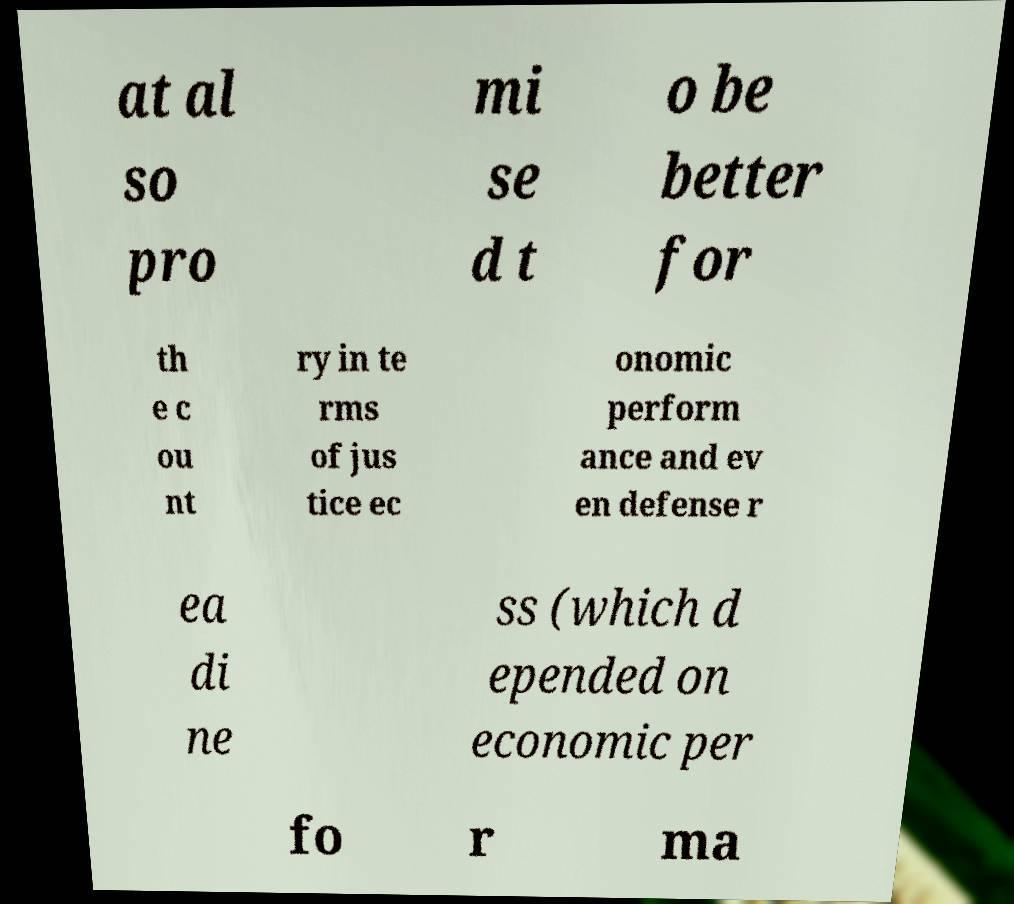There's text embedded in this image that I need extracted. Can you transcribe it verbatim? at al so pro mi se d t o be better for th e c ou nt ry in te rms of jus tice ec onomic perform ance and ev en defense r ea di ne ss (which d epended on economic per fo r ma 